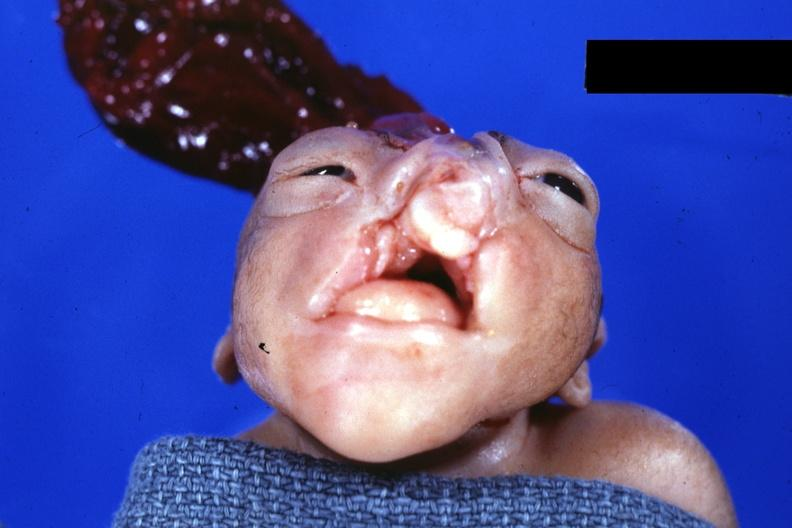what is present?
Answer the question using a single word or phrase. Anencephaly and bilateral cleft palate 